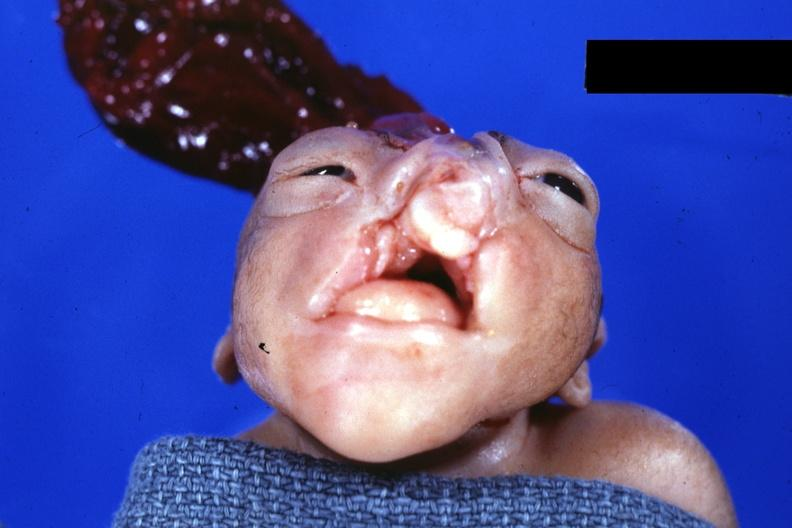what is present?
Answer the question using a single word or phrase. Anencephaly and bilateral cleft palate 